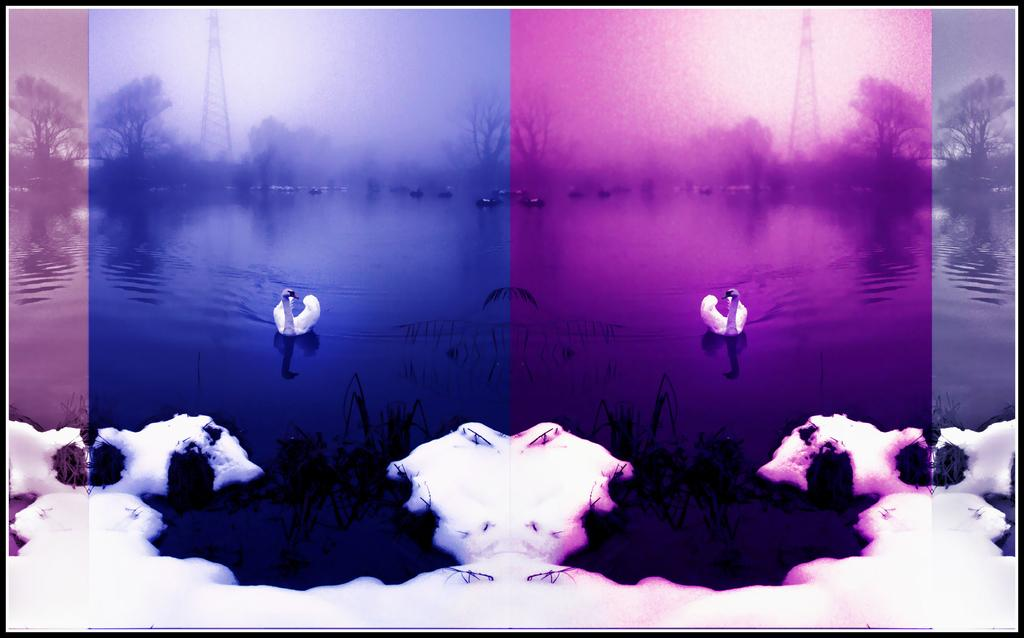What colors are predominant in the image? The image has a pink and violet color scheme. What type of weather is depicted in the image? There is snow depicted in the image. What animals can be seen in the water? There are ducks in the water. What structures can be seen in the background of the image? There is a tower and a tree in the background of the image. Can you see a basin filled with feathers in the image? There is no basin filled with feathers present in the image. Are there any deer visible in the image? There are no deer visible in the image; it features ducks in the water. 